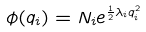Convert formula to latex. <formula><loc_0><loc_0><loc_500><loc_500>\phi ( q _ { i } ) = N _ { i } e ^ { \frac { 1 } { 2 } \lambda _ { i } q ^ { 2 } _ { i } }</formula> 